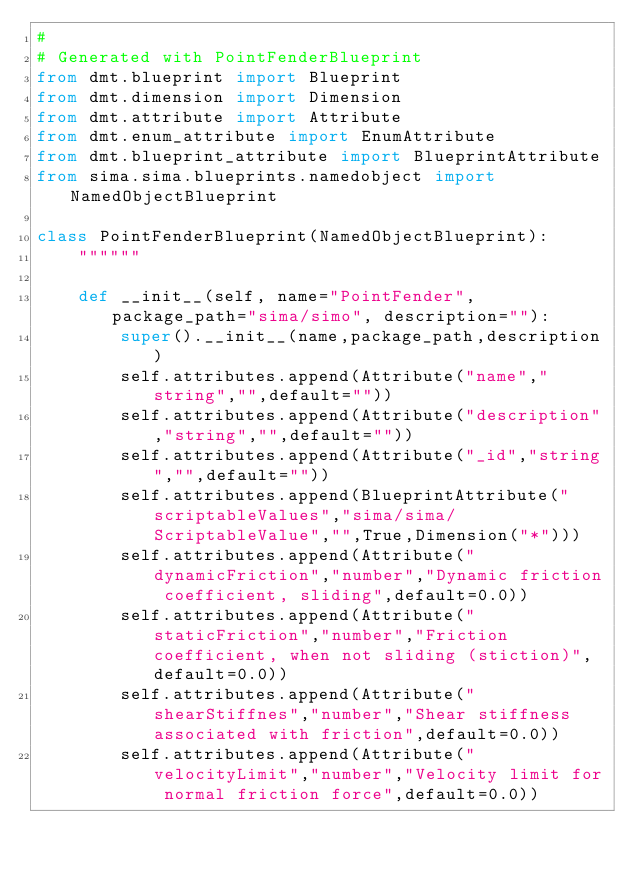Convert code to text. <code><loc_0><loc_0><loc_500><loc_500><_Python_># 
# Generated with PointFenderBlueprint
from dmt.blueprint import Blueprint
from dmt.dimension import Dimension
from dmt.attribute import Attribute
from dmt.enum_attribute import EnumAttribute
from dmt.blueprint_attribute import BlueprintAttribute
from sima.sima.blueprints.namedobject import NamedObjectBlueprint

class PointFenderBlueprint(NamedObjectBlueprint):
    """"""

    def __init__(self, name="PointFender", package_path="sima/simo", description=""):
        super().__init__(name,package_path,description)
        self.attributes.append(Attribute("name","string","",default=""))
        self.attributes.append(Attribute("description","string","",default=""))
        self.attributes.append(Attribute("_id","string","",default=""))
        self.attributes.append(BlueprintAttribute("scriptableValues","sima/sima/ScriptableValue","",True,Dimension("*")))
        self.attributes.append(Attribute("dynamicFriction","number","Dynamic friction coefficient, sliding",default=0.0))
        self.attributes.append(Attribute("staticFriction","number","Friction coefficient, when not sliding (stiction)",default=0.0))
        self.attributes.append(Attribute("shearStiffnes","number","Shear stiffness associated with friction",default=0.0))
        self.attributes.append(Attribute("velocityLimit","number","Velocity limit for normal friction force",default=0.0))</code> 